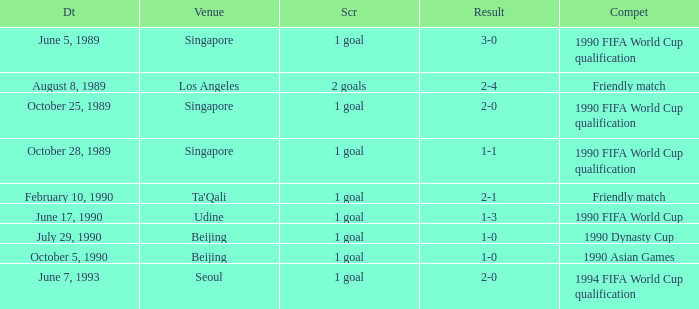What is the score of the match on October 5, 1990? 1 goal. 